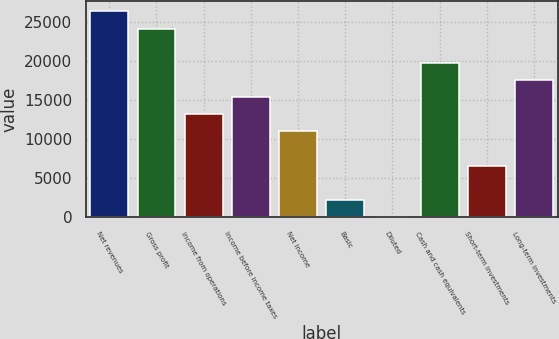Convert chart to OTSL. <chart><loc_0><loc_0><loc_500><loc_500><bar_chart><fcel>Net revenues<fcel>Gross profit<fcel>Income from operations<fcel>Income before income taxes<fcel>Net income<fcel>Basic<fcel>Diluted<fcel>Cash and cash equivalents<fcel>Short-term investments<fcel>Long-term investments<nl><fcel>26404.5<fcel>24204.2<fcel>13202.9<fcel>15403.2<fcel>11002.7<fcel>2201.62<fcel>1.36<fcel>19803.7<fcel>6602.14<fcel>17603.4<nl></chart> 